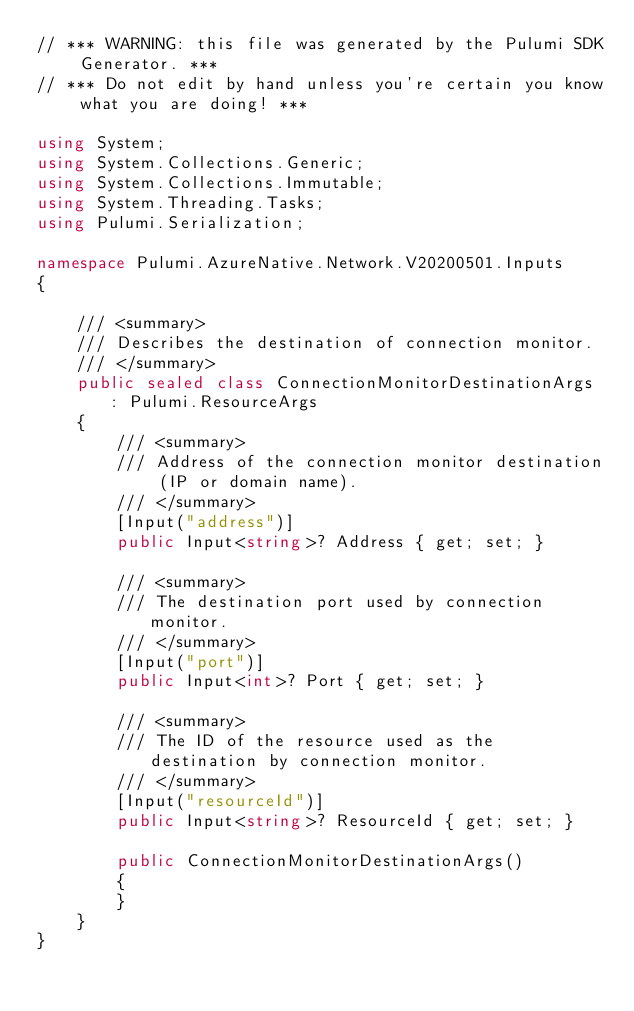<code> <loc_0><loc_0><loc_500><loc_500><_C#_>// *** WARNING: this file was generated by the Pulumi SDK Generator. ***
// *** Do not edit by hand unless you're certain you know what you are doing! ***

using System;
using System.Collections.Generic;
using System.Collections.Immutable;
using System.Threading.Tasks;
using Pulumi.Serialization;

namespace Pulumi.AzureNative.Network.V20200501.Inputs
{

    /// <summary>
    /// Describes the destination of connection monitor.
    /// </summary>
    public sealed class ConnectionMonitorDestinationArgs : Pulumi.ResourceArgs
    {
        /// <summary>
        /// Address of the connection monitor destination (IP or domain name).
        /// </summary>
        [Input("address")]
        public Input<string>? Address { get; set; }

        /// <summary>
        /// The destination port used by connection monitor.
        /// </summary>
        [Input("port")]
        public Input<int>? Port { get; set; }

        /// <summary>
        /// The ID of the resource used as the destination by connection monitor.
        /// </summary>
        [Input("resourceId")]
        public Input<string>? ResourceId { get; set; }

        public ConnectionMonitorDestinationArgs()
        {
        }
    }
}
</code> 